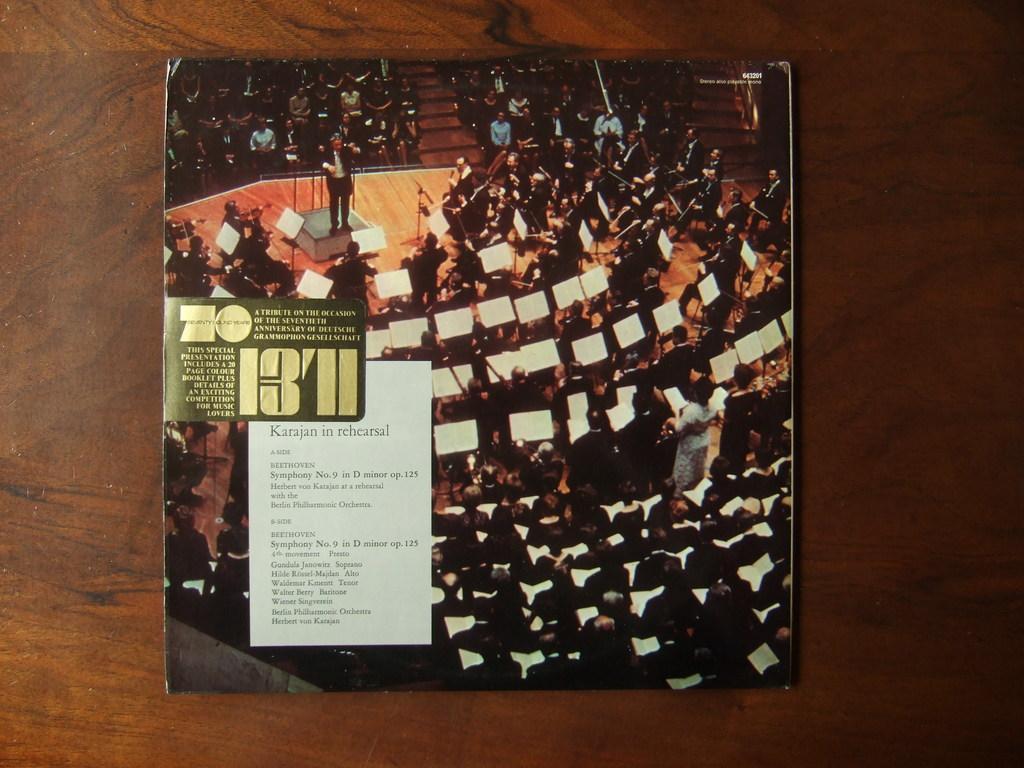Please provide a concise description of this image. In the picture I can see the music album cover photo on the wooden table. On the cover photo I can see a group of people playing the musical instruments. 